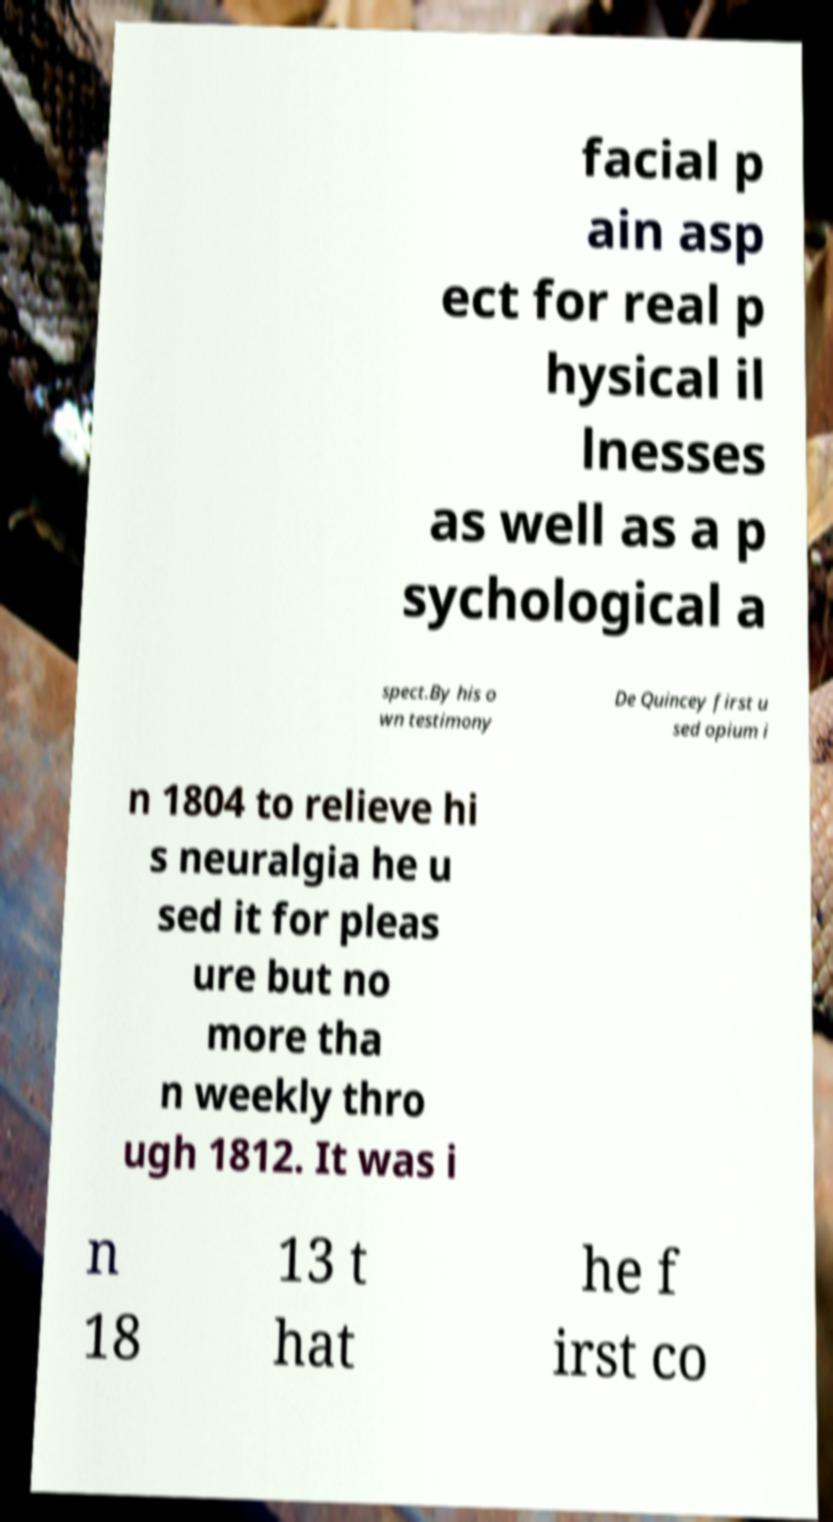Can you read and provide the text displayed in the image?This photo seems to have some interesting text. Can you extract and type it out for me? facial p ain asp ect for real p hysical il lnesses as well as a p sychological a spect.By his o wn testimony De Quincey first u sed opium i n 1804 to relieve hi s neuralgia he u sed it for pleas ure but no more tha n weekly thro ugh 1812. It was i n 18 13 t hat he f irst co 